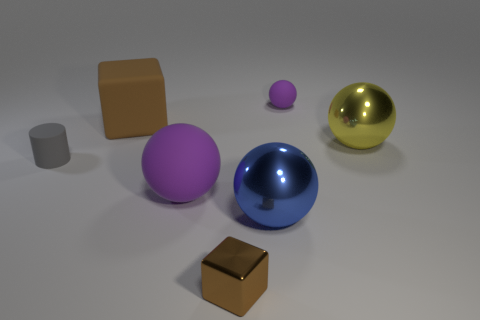Add 2 large blue spheres. How many objects exist? 9 How many purple balls must be subtracted to get 1 purple balls? 1 Subtract all tiny purple rubber balls. How many balls are left? 3 Subtract 1 blocks. How many blocks are left? 1 Add 4 rubber cylinders. How many rubber cylinders are left? 5 Add 2 tiny brown objects. How many tiny brown objects exist? 3 Subtract all blue spheres. How many spheres are left? 3 Subtract 0 yellow blocks. How many objects are left? 7 Subtract all cylinders. How many objects are left? 6 Subtract all red blocks. Subtract all cyan balls. How many blocks are left? 2 